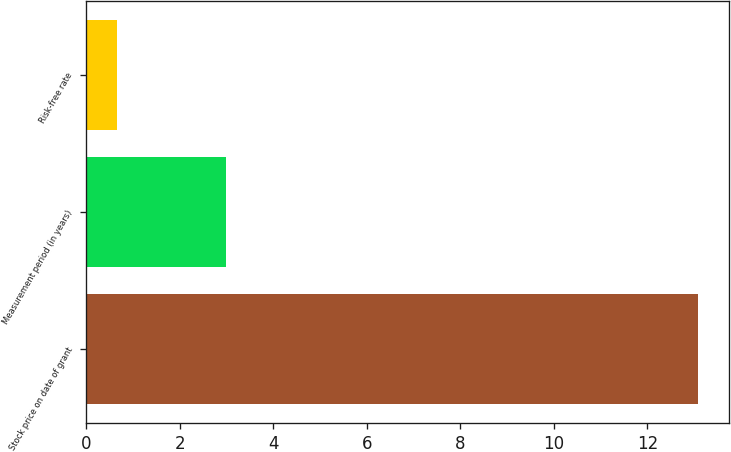Convert chart. <chart><loc_0><loc_0><loc_500><loc_500><bar_chart><fcel>Stock price on date of grant<fcel>Measurement period (in years)<fcel>Risk-free rate<nl><fcel>13.08<fcel>3<fcel>0.66<nl></chart> 